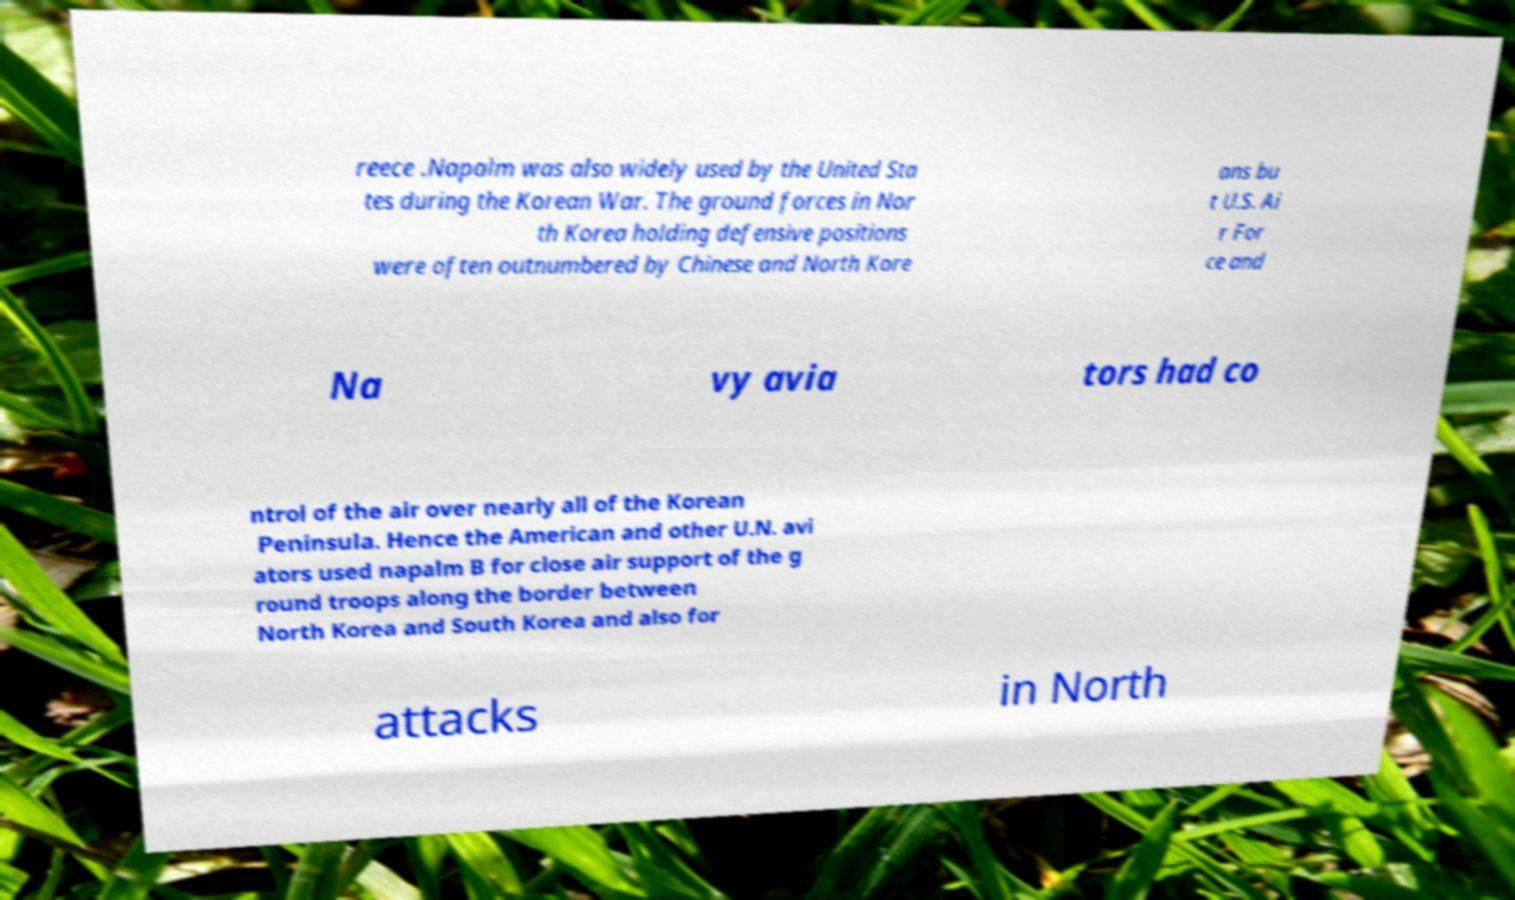Can you read and provide the text displayed in the image?This photo seems to have some interesting text. Can you extract and type it out for me? reece .Napalm was also widely used by the United Sta tes during the Korean War. The ground forces in Nor th Korea holding defensive positions were often outnumbered by Chinese and North Kore ans bu t U.S. Ai r For ce and Na vy avia tors had co ntrol of the air over nearly all of the Korean Peninsula. Hence the American and other U.N. avi ators used napalm B for close air support of the g round troops along the border between North Korea and South Korea and also for attacks in North 